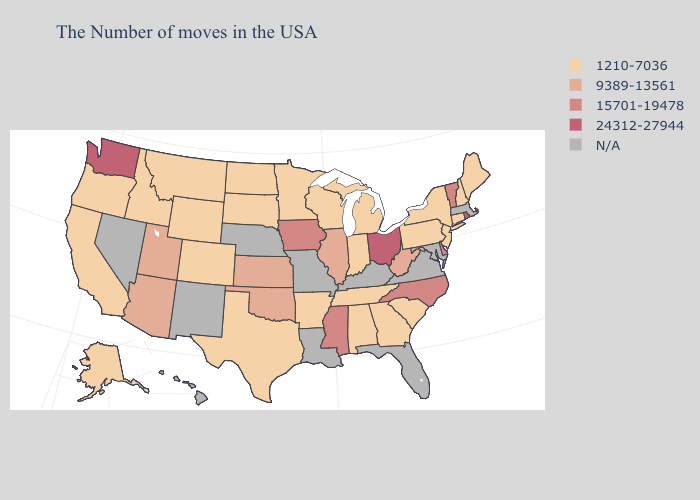Which states have the lowest value in the USA?
Short answer required. Maine, New Hampshire, Connecticut, New York, New Jersey, Pennsylvania, South Carolina, Georgia, Michigan, Indiana, Alabama, Tennessee, Wisconsin, Arkansas, Minnesota, Texas, South Dakota, North Dakota, Wyoming, Colorado, Montana, Idaho, California, Oregon, Alaska. What is the lowest value in states that border Colorado?
Be succinct. 1210-7036. What is the lowest value in states that border Florida?
Give a very brief answer. 1210-7036. Name the states that have a value in the range 9389-13561?
Concise answer only. West Virginia, Illinois, Kansas, Oklahoma, Utah, Arizona. What is the highest value in the South ?
Quick response, please. 15701-19478. Among the states that border Georgia , does North Carolina have the lowest value?
Answer briefly. No. Name the states that have a value in the range 1210-7036?
Concise answer only. Maine, New Hampshire, Connecticut, New York, New Jersey, Pennsylvania, South Carolina, Georgia, Michigan, Indiana, Alabama, Tennessee, Wisconsin, Arkansas, Minnesota, Texas, South Dakota, North Dakota, Wyoming, Colorado, Montana, Idaho, California, Oregon, Alaska. What is the highest value in the Northeast ?
Answer briefly. 24312-27944. Name the states that have a value in the range 1210-7036?
Quick response, please. Maine, New Hampshire, Connecticut, New York, New Jersey, Pennsylvania, South Carolina, Georgia, Michigan, Indiana, Alabama, Tennessee, Wisconsin, Arkansas, Minnesota, Texas, South Dakota, North Dakota, Wyoming, Colorado, Montana, Idaho, California, Oregon, Alaska. What is the value of New York?
Keep it brief. 1210-7036. Does Arizona have the lowest value in the USA?
Keep it brief. No. Name the states that have a value in the range N/A?
Quick response, please. Massachusetts, Maryland, Virginia, Florida, Kentucky, Louisiana, Missouri, Nebraska, New Mexico, Nevada, Hawaii. What is the highest value in states that border Rhode Island?
Give a very brief answer. 1210-7036. Does the map have missing data?
Answer briefly. Yes. 